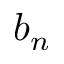Convert formula to latex. <formula><loc_0><loc_0><loc_500><loc_500>b _ { n }</formula> 